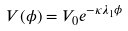<formula> <loc_0><loc_0><loc_500><loc_500>V ( \phi ) = V _ { 0 } e ^ { - \kappa \lambda _ { 1 } \phi }</formula> 